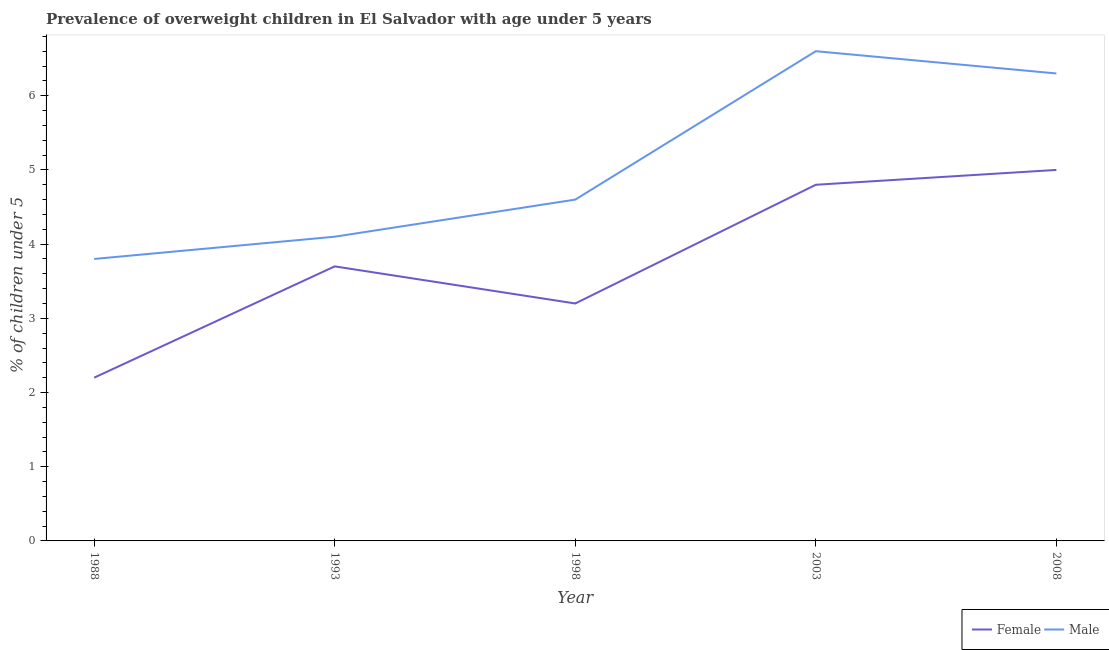Does the line corresponding to percentage of obese female children intersect with the line corresponding to percentage of obese male children?
Provide a short and direct response. No. What is the percentage of obese male children in 1993?
Offer a terse response. 4.1. Across all years, what is the maximum percentage of obese male children?
Ensure brevity in your answer.  6.6. Across all years, what is the minimum percentage of obese female children?
Give a very brief answer. 2.2. What is the total percentage of obese male children in the graph?
Provide a short and direct response. 25.4. What is the difference between the percentage of obese female children in 1993 and that in 2008?
Provide a short and direct response. -1.3. What is the difference between the percentage of obese female children in 2003 and the percentage of obese male children in 1993?
Make the answer very short. 0.7. What is the average percentage of obese female children per year?
Offer a terse response. 3.78. In the year 2003, what is the difference between the percentage of obese male children and percentage of obese female children?
Offer a terse response. 1.8. What is the ratio of the percentage of obese male children in 1993 to that in 2008?
Offer a terse response. 0.65. Is the difference between the percentage of obese male children in 1998 and 2008 greater than the difference between the percentage of obese female children in 1998 and 2008?
Keep it short and to the point. Yes. What is the difference between the highest and the second highest percentage of obese male children?
Provide a succinct answer. 0.3. What is the difference between the highest and the lowest percentage of obese male children?
Keep it short and to the point. 2.8. In how many years, is the percentage of obese female children greater than the average percentage of obese female children taken over all years?
Keep it short and to the point. 2. Is the sum of the percentage of obese female children in 1993 and 2003 greater than the maximum percentage of obese male children across all years?
Your answer should be very brief. Yes. Is the percentage of obese female children strictly greater than the percentage of obese male children over the years?
Ensure brevity in your answer.  No. Is the percentage of obese male children strictly less than the percentage of obese female children over the years?
Keep it short and to the point. No. How many lines are there?
Your answer should be very brief. 2. How many years are there in the graph?
Make the answer very short. 5. Does the graph contain any zero values?
Keep it short and to the point. No. Where does the legend appear in the graph?
Offer a very short reply. Bottom right. How many legend labels are there?
Give a very brief answer. 2. How are the legend labels stacked?
Offer a very short reply. Horizontal. What is the title of the graph?
Your response must be concise. Prevalence of overweight children in El Salvador with age under 5 years. What is the label or title of the Y-axis?
Provide a short and direct response.  % of children under 5. What is the  % of children under 5 of Female in 1988?
Make the answer very short. 2.2. What is the  % of children under 5 of Male in 1988?
Ensure brevity in your answer.  3.8. What is the  % of children under 5 in Female in 1993?
Give a very brief answer. 3.7. What is the  % of children under 5 of Male in 1993?
Offer a terse response. 4.1. What is the  % of children under 5 in Female in 1998?
Give a very brief answer. 3.2. What is the  % of children under 5 in Male in 1998?
Offer a very short reply. 4.6. What is the  % of children under 5 in Female in 2003?
Provide a short and direct response. 4.8. What is the  % of children under 5 of Male in 2003?
Keep it short and to the point. 6.6. What is the  % of children under 5 of Female in 2008?
Your answer should be compact. 5. What is the  % of children under 5 of Male in 2008?
Ensure brevity in your answer.  6.3. Across all years, what is the maximum  % of children under 5 in Female?
Provide a succinct answer. 5. Across all years, what is the maximum  % of children under 5 in Male?
Provide a short and direct response. 6.6. Across all years, what is the minimum  % of children under 5 of Female?
Make the answer very short. 2.2. Across all years, what is the minimum  % of children under 5 of Male?
Ensure brevity in your answer.  3.8. What is the total  % of children under 5 in Female in the graph?
Keep it short and to the point. 18.9. What is the total  % of children under 5 of Male in the graph?
Provide a short and direct response. 25.4. What is the difference between the  % of children under 5 in Female in 1988 and that in 2003?
Give a very brief answer. -2.6. What is the difference between the  % of children under 5 in Male in 1988 and that in 2003?
Keep it short and to the point. -2.8. What is the difference between the  % of children under 5 of Female in 1988 and that in 2008?
Your response must be concise. -2.8. What is the difference between the  % of children under 5 of Male in 1988 and that in 2008?
Offer a very short reply. -2.5. What is the difference between the  % of children under 5 of Female in 1993 and that in 1998?
Provide a succinct answer. 0.5. What is the difference between the  % of children under 5 in Male in 1993 and that in 1998?
Offer a very short reply. -0.5. What is the difference between the  % of children under 5 of Female in 1993 and that in 2003?
Give a very brief answer. -1.1. What is the difference between the  % of children under 5 in Female in 1993 and that in 2008?
Provide a succinct answer. -1.3. What is the difference between the  % of children under 5 in Male in 1993 and that in 2008?
Your answer should be very brief. -2.2. What is the difference between the  % of children under 5 in Female in 1988 and the  % of children under 5 in Male in 2008?
Provide a short and direct response. -4.1. What is the difference between the  % of children under 5 in Female in 1993 and the  % of children under 5 in Male in 1998?
Your answer should be compact. -0.9. What is the average  % of children under 5 in Female per year?
Ensure brevity in your answer.  3.78. What is the average  % of children under 5 in Male per year?
Your answer should be compact. 5.08. In the year 1988, what is the difference between the  % of children under 5 in Female and  % of children under 5 in Male?
Provide a short and direct response. -1.6. In the year 1993, what is the difference between the  % of children under 5 in Female and  % of children under 5 in Male?
Your answer should be very brief. -0.4. What is the ratio of the  % of children under 5 in Female in 1988 to that in 1993?
Provide a short and direct response. 0.59. What is the ratio of the  % of children under 5 of Male in 1988 to that in 1993?
Provide a short and direct response. 0.93. What is the ratio of the  % of children under 5 in Female in 1988 to that in 1998?
Offer a terse response. 0.69. What is the ratio of the  % of children under 5 of Male in 1988 to that in 1998?
Offer a very short reply. 0.83. What is the ratio of the  % of children under 5 in Female in 1988 to that in 2003?
Offer a very short reply. 0.46. What is the ratio of the  % of children under 5 in Male in 1988 to that in 2003?
Make the answer very short. 0.58. What is the ratio of the  % of children under 5 of Female in 1988 to that in 2008?
Your answer should be compact. 0.44. What is the ratio of the  % of children under 5 in Male in 1988 to that in 2008?
Keep it short and to the point. 0.6. What is the ratio of the  % of children under 5 in Female in 1993 to that in 1998?
Your answer should be compact. 1.16. What is the ratio of the  % of children under 5 of Male in 1993 to that in 1998?
Keep it short and to the point. 0.89. What is the ratio of the  % of children under 5 of Female in 1993 to that in 2003?
Keep it short and to the point. 0.77. What is the ratio of the  % of children under 5 in Male in 1993 to that in 2003?
Give a very brief answer. 0.62. What is the ratio of the  % of children under 5 in Female in 1993 to that in 2008?
Give a very brief answer. 0.74. What is the ratio of the  % of children under 5 of Male in 1993 to that in 2008?
Ensure brevity in your answer.  0.65. What is the ratio of the  % of children under 5 of Female in 1998 to that in 2003?
Offer a very short reply. 0.67. What is the ratio of the  % of children under 5 in Male in 1998 to that in 2003?
Your answer should be very brief. 0.7. What is the ratio of the  % of children under 5 of Female in 1998 to that in 2008?
Keep it short and to the point. 0.64. What is the ratio of the  % of children under 5 of Male in 1998 to that in 2008?
Your answer should be very brief. 0.73. What is the ratio of the  % of children under 5 in Male in 2003 to that in 2008?
Provide a succinct answer. 1.05. What is the difference between the highest and the second highest  % of children under 5 of Male?
Ensure brevity in your answer.  0.3. What is the difference between the highest and the lowest  % of children under 5 in Female?
Offer a very short reply. 2.8. What is the difference between the highest and the lowest  % of children under 5 in Male?
Your answer should be compact. 2.8. 